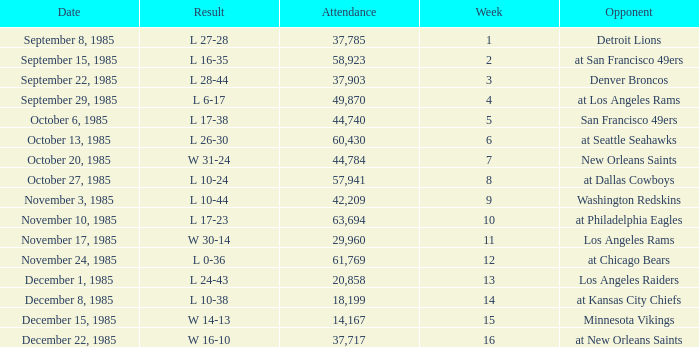Who was the opponent the falcons played against on week 3? Denver Broncos. 